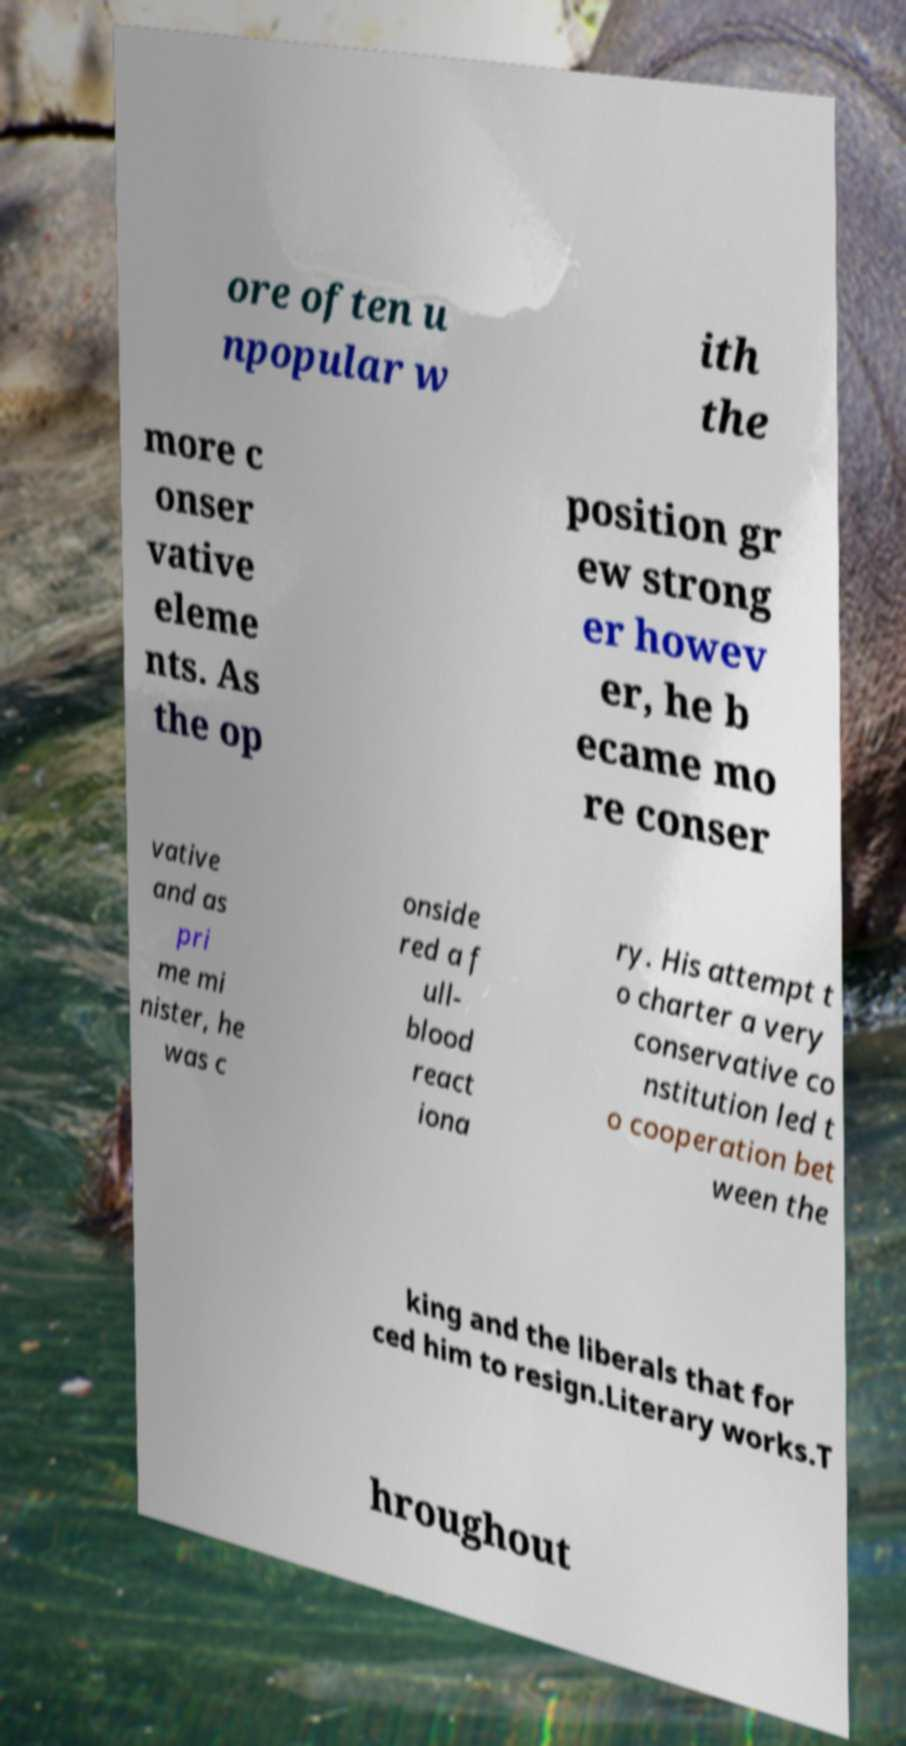Can you accurately transcribe the text from the provided image for me? ore often u npopular w ith the more c onser vative eleme nts. As the op position gr ew strong er howev er, he b ecame mo re conser vative and as pri me mi nister, he was c onside red a f ull- blood react iona ry. His attempt t o charter a very conservative co nstitution led t o cooperation bet ween the king and the liberals that for ced him to resign.Literary works.T hroughout 